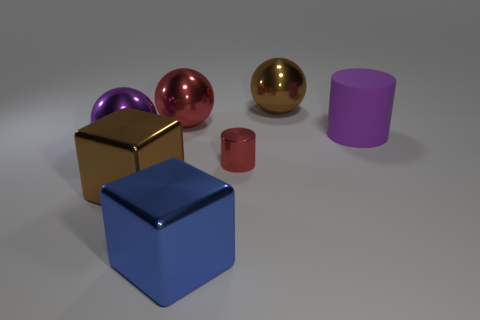Add 1 purple matte things. How many objects exist? 8 Subtract all blocks. How many objects are left? 5 Subtract all yellow metal cylinders. Subtract all purple matte things. How many objects are left? 6 Add 6 tiny metal things. How many tiny metal things are left? 7 Add 1 big metal cubes. How many big metal cubes exist? 3 Subtract 0 brown cylinders. How many objects are left? 7 